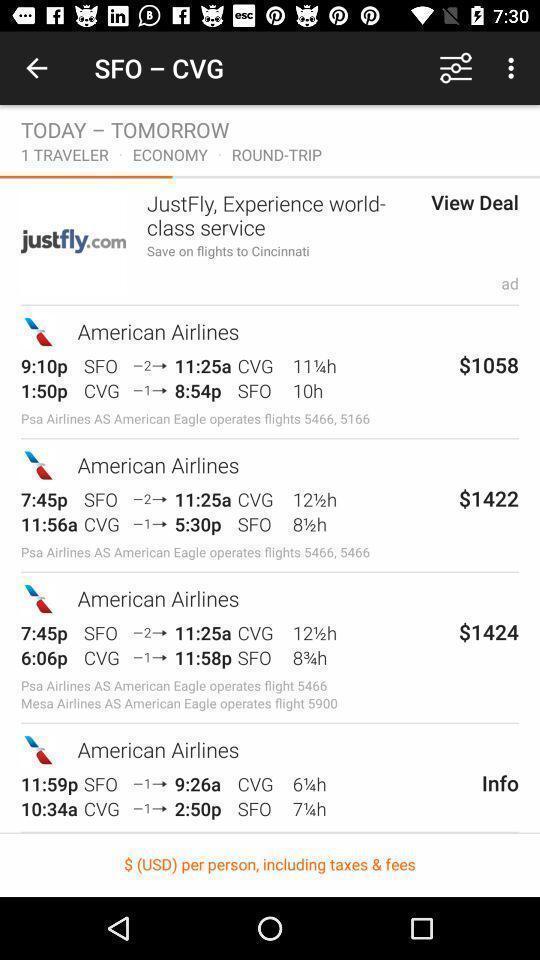What can you discern from this picture? Page showing list of flight availability and price details. 